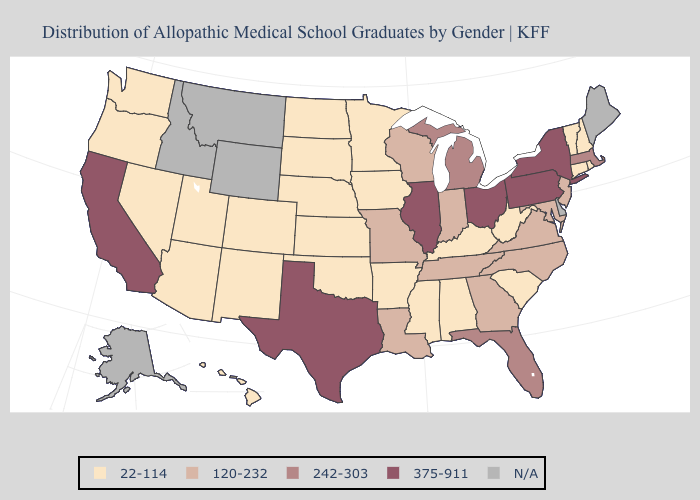Does the first symbol in the legend represent the smallest category?
Be succinct. Yes. Name the states that have a value in the range 120-232?
Short answer required. Georgia, Indiana, Louisiana, Maryland, Missouri, New Jersey, North Carolina, Tennessee, Virginia, Wisconsin. Which states have the highest value in the USA?
Answer briefly. California, Illinois, New York, Ohio, Pennsylvania, Texas. Name the states that have a value in the range 242-303?
Give a very brief answer. Florida, Massachusetts, Michigan. Does the map have missing data?
Answer briefly. Yes. What is the value of Missouri?
Give a very brief answer. 120-232. What is the value of Delaware?
Short answer required. N/A. What is the value of Louisiana?
Answer briefly. 120-232. Does Florida have the highest value in the USA?
Quick response, please. No. What is the highest value in states that border Nebraska?
Quick response, please. 120-232. Which states have the lowest value in the South?
Write a very short answer. Alabama, Arkansas, Kentucky, Mississippi, Oklahoma, South Carolina, West Virginia. Does the first symbol in the legend represent the smallest category?
Write a very short answer. Yes. Name the states that have a value in the range 22-114?
Keep it brief. Alabama, Arizona, Arkansas, Colorado, Connecticut, Hawaii, Iowa, Kansas, Kentucky, Minnesota, Mississippi, Nebraska, Nevada, New Hampshire, New Mexico, North Dakota, Oklahoma, Oregon, Rhode Island, South Carolina, South Dakota, Utah, Vermont, Washington, West Virginia. 